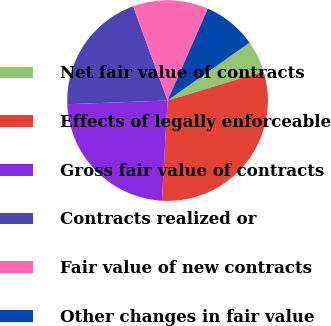Convert chart to OTSL. <chart><loc_0><loc_0><loc_500><loc_500><pie_chart><fcel>Net fair value of contracts<fcel>Effects of legally enforceable<fcel>Gross fair value of contracts<fcel>Contracts realized or<fcel>Fair value of new contracts<fcel>Other changes in fair value<nl><fcel>5.13%<fcel>30.57%<fcel>23.52%<fcel>20.01%<fcel>12.14%<fcel>8.63%<nl></chart> 